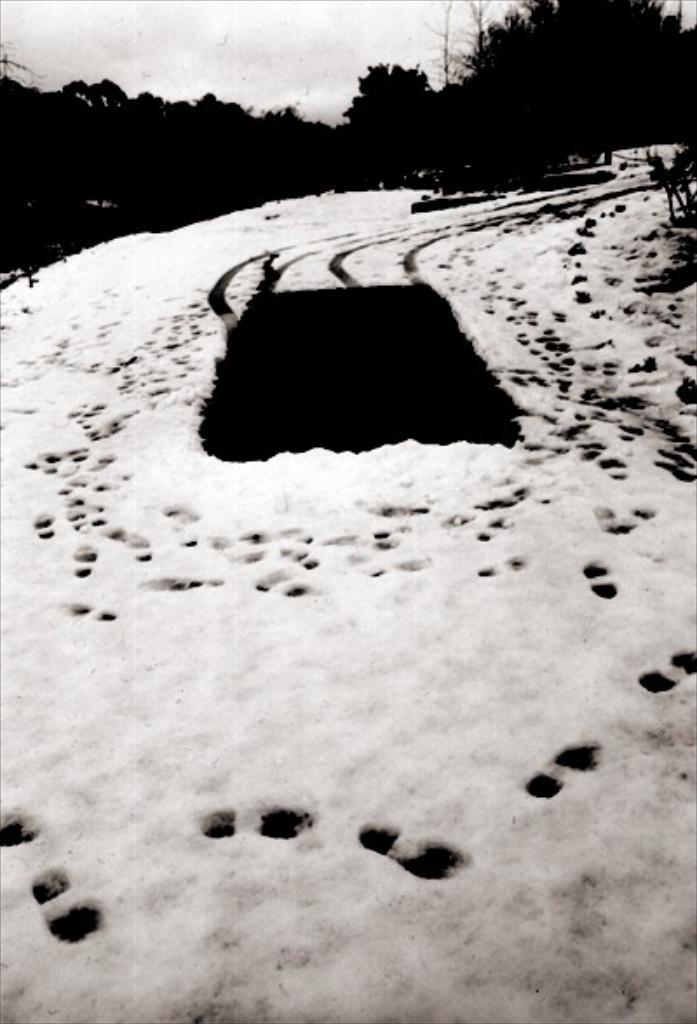What type of weather condition is depicted in the image? There is snow in the front of the image, indicating a snowy or wintry scene. What can be seen in the background of the image? There are trees in the background of the image. What is the color of the object in the center of the image? The object in the center of the image is black in color. How does the snow stretch across the image? The snow does not stretch across the image; it is depicted in a specific area of the image. 